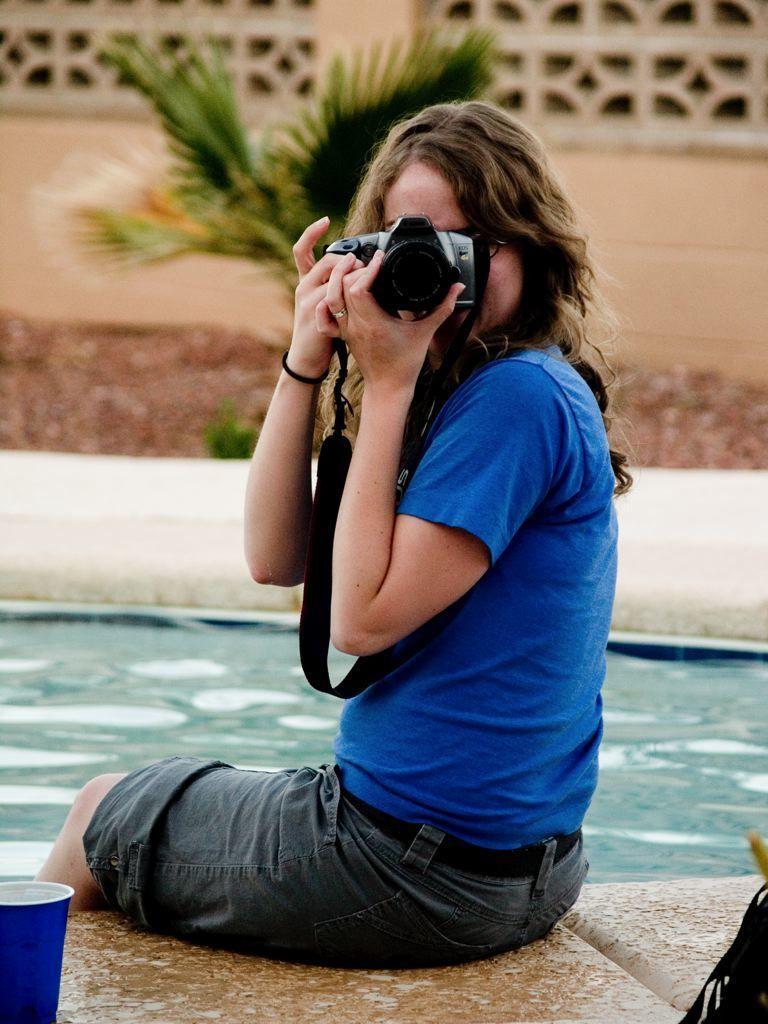In one or two sentences, can you explain what this image depicts? In this image I see a woman who is holding a camera and sitting in front of the pool and there is a cup over here. In the background I see the plants. 